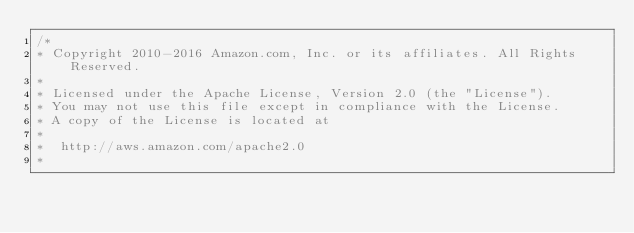<code> <loc_0><loc_0><loc_500><loc_500><_C_>/*
* Copyright 2010-2016 Amazon.com, Inc. or its affiliates. All Rights Reserved.
*
* Licensed under the Apache License, Version 2.0 (the "License").
* You may not use this file except in compliance with the License.
* A copy of the License is located at
*
*  http://aws.amazon.com/apache2.0
*</code> 